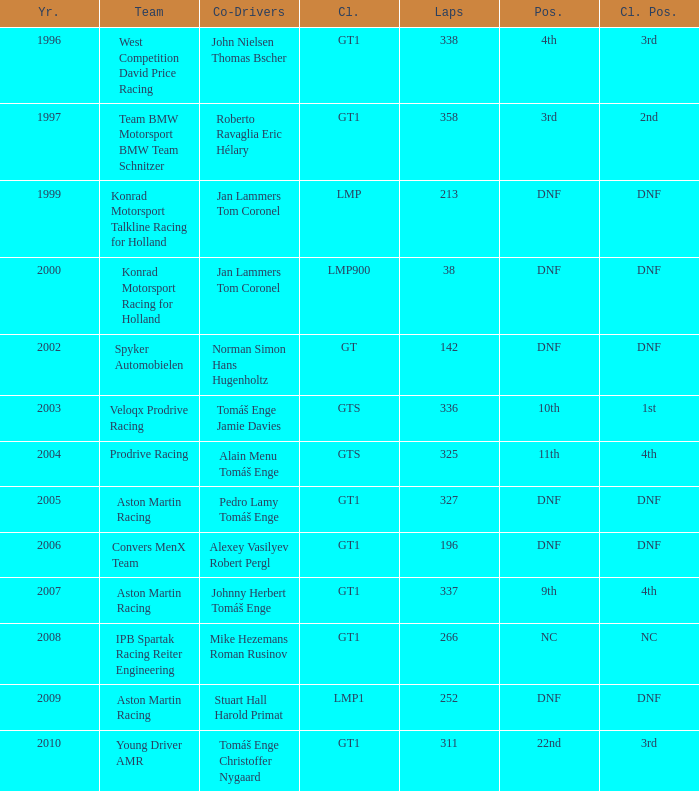What was the status in 1997? 3rd. Would you mind parsing the complete table? {'header': ['Yr.', 'Team', 'Co-Drivers', 'Cl.', 'Laps', 'Pos.', 'Cl. Pos.'], 'rows': [['1996', 'West Competition David Price Racing', 'John Nielsen Thomas Bscher', 'GT1', '338', '4th', '3rd'], ['1997', 'Team BMW Motorsport BMW Team Schnitzer', 'Roberto Ravaglia Eric Hélary', 'GT1', '358', '3rd', '2nd'], ['1999', 'Konrad Motorsport Talkline Racing for Holland', 'Jan Lammers Tom Coronel', 'LMP', '213', 'DNF', 'DNF'], ['2000', 'Konrad Motorsport Racing for Holland', 'Jan Lammers Tom Coronel', 'LMP900', '38', 'DNF', 'DNF'], ['2002', 'Spyker Automobielen', 'Norman Simon Hans Hugenholtz', 'GT', '142', 'DNF', 'DNF'], ['2003', 'Veloqx Prodrive Racing', 'Tomáš Enge Jamie Davies', 'GTS', '336', '10th', '1st'], ['2004', 'Prodrive Racing', 'Alain Menu Tomáš Enge', 'GTS', '325', '11th', '4th'], ['2005', 'Aston Martin Racing', 'Pedro Lamy Tomáš Enge', 'GT1', '327', 'DNF', 'DNF'], ['2006', 'Convers MenX Team', 'Alexey Vasilyev Robert Pergl', 'GT1', '196', 'DNF', 'DNF'], ['2007', 'Aston Martin Racing', 'Johnny Herbert Tomáš Enge', 'GT1', '337', '9th', '4th'], ['2008', 'IPB Spartak Racing Reiter Engineering', 'Mike Hezemans Roman Rusinov', 'GT1', '266', 'NC', 'NC'], ['2009', 'Aston Martin Racing', 'Stuart Hall Harold Primat', 'LMP1', '252', 'DNF', 'DNF'], ['2010', 'Young Driver AMR', 'Tomáš Enge Christoffer Nygaard', 'GT1', '311', '22nd', '3rd']]} 